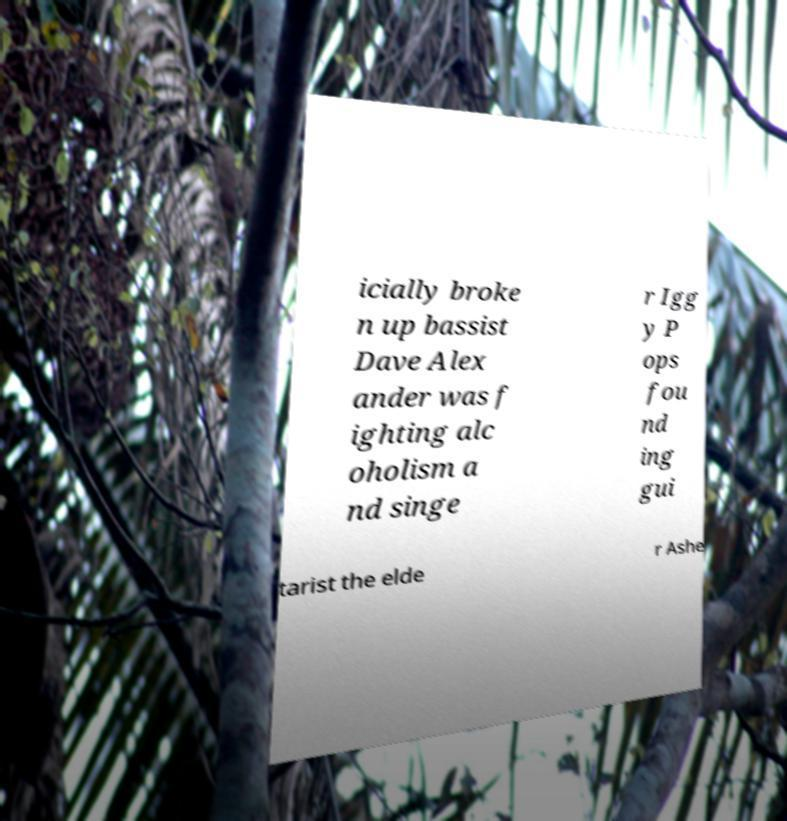Can you read and provide the text displayed in the image?This photo seems to have some interesting text. Can you extract and type it out for me? icially broke n up bassist Dave Alex ander was f ighting alc oholism a nd singe r Igg y P ops fou nd ing gui tarist the elde r Ashe 